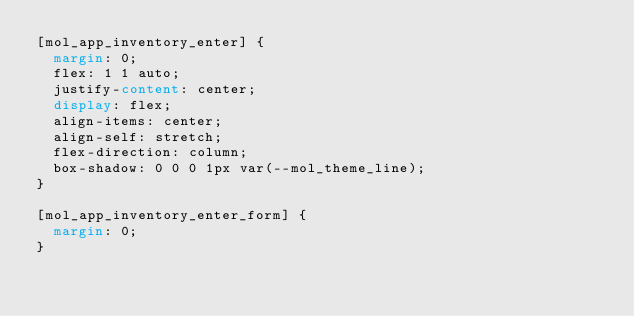Convert code to text. <code><loc_0><loc_0><loc_500><loc_500><_CSS_>[mol_app_inventory_enter] {
	margin: 0;
	flex: 1 1 auto;
	justify-content: center;
	display: flex;
	align-items: center;
	align-self: stretch;
	flex-direction: column;
	box-shadow: 0 0 0 1px var(--mol_theme_line);
}

[mol_app_inventory_enter_form] {
	margin: 0;
}
</code> 